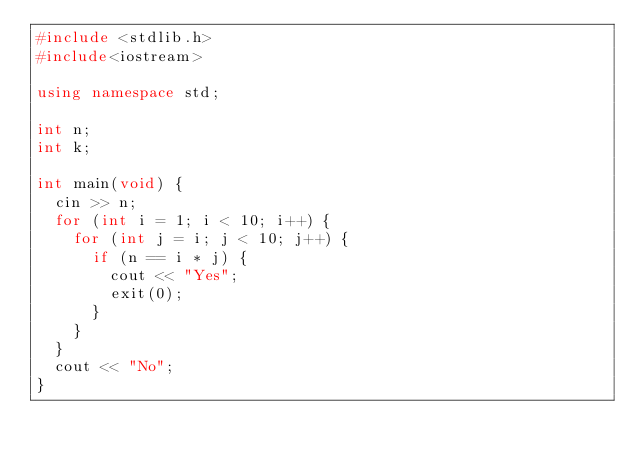Convert code to text. <code><loc_0><loc_0><loc_500><loc_500><_C++_>#include <stdlib.h>
#include<iostream>

using namespace std;

int n;
int k;

int main(void) {
	cin >> n;
	for (int i = 1; i < 10; i++) {
		for (int j = i; j < 10; j++) {
			if (n == i * j) {
				cout << "Yes";
				exit(0);
			}
		}
	}
	cout << "No";
}</code> 